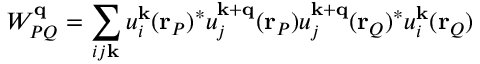Convert formula to latex. <formula><loc_0><loc_0><loc_500><loc_500>W _ { P Q } ^ { q } = \sum _ { i j k } u _ { i } ^ { k } ( r _ { P } ) ^ { * } u _ { j } ^ { k + q } ( r _ { P } ) u _ { j } ^ { k + q } ( r _ { Q } ) ^ { * } u _ { i } ^ { k } ( r _ { Q } )</formula> 